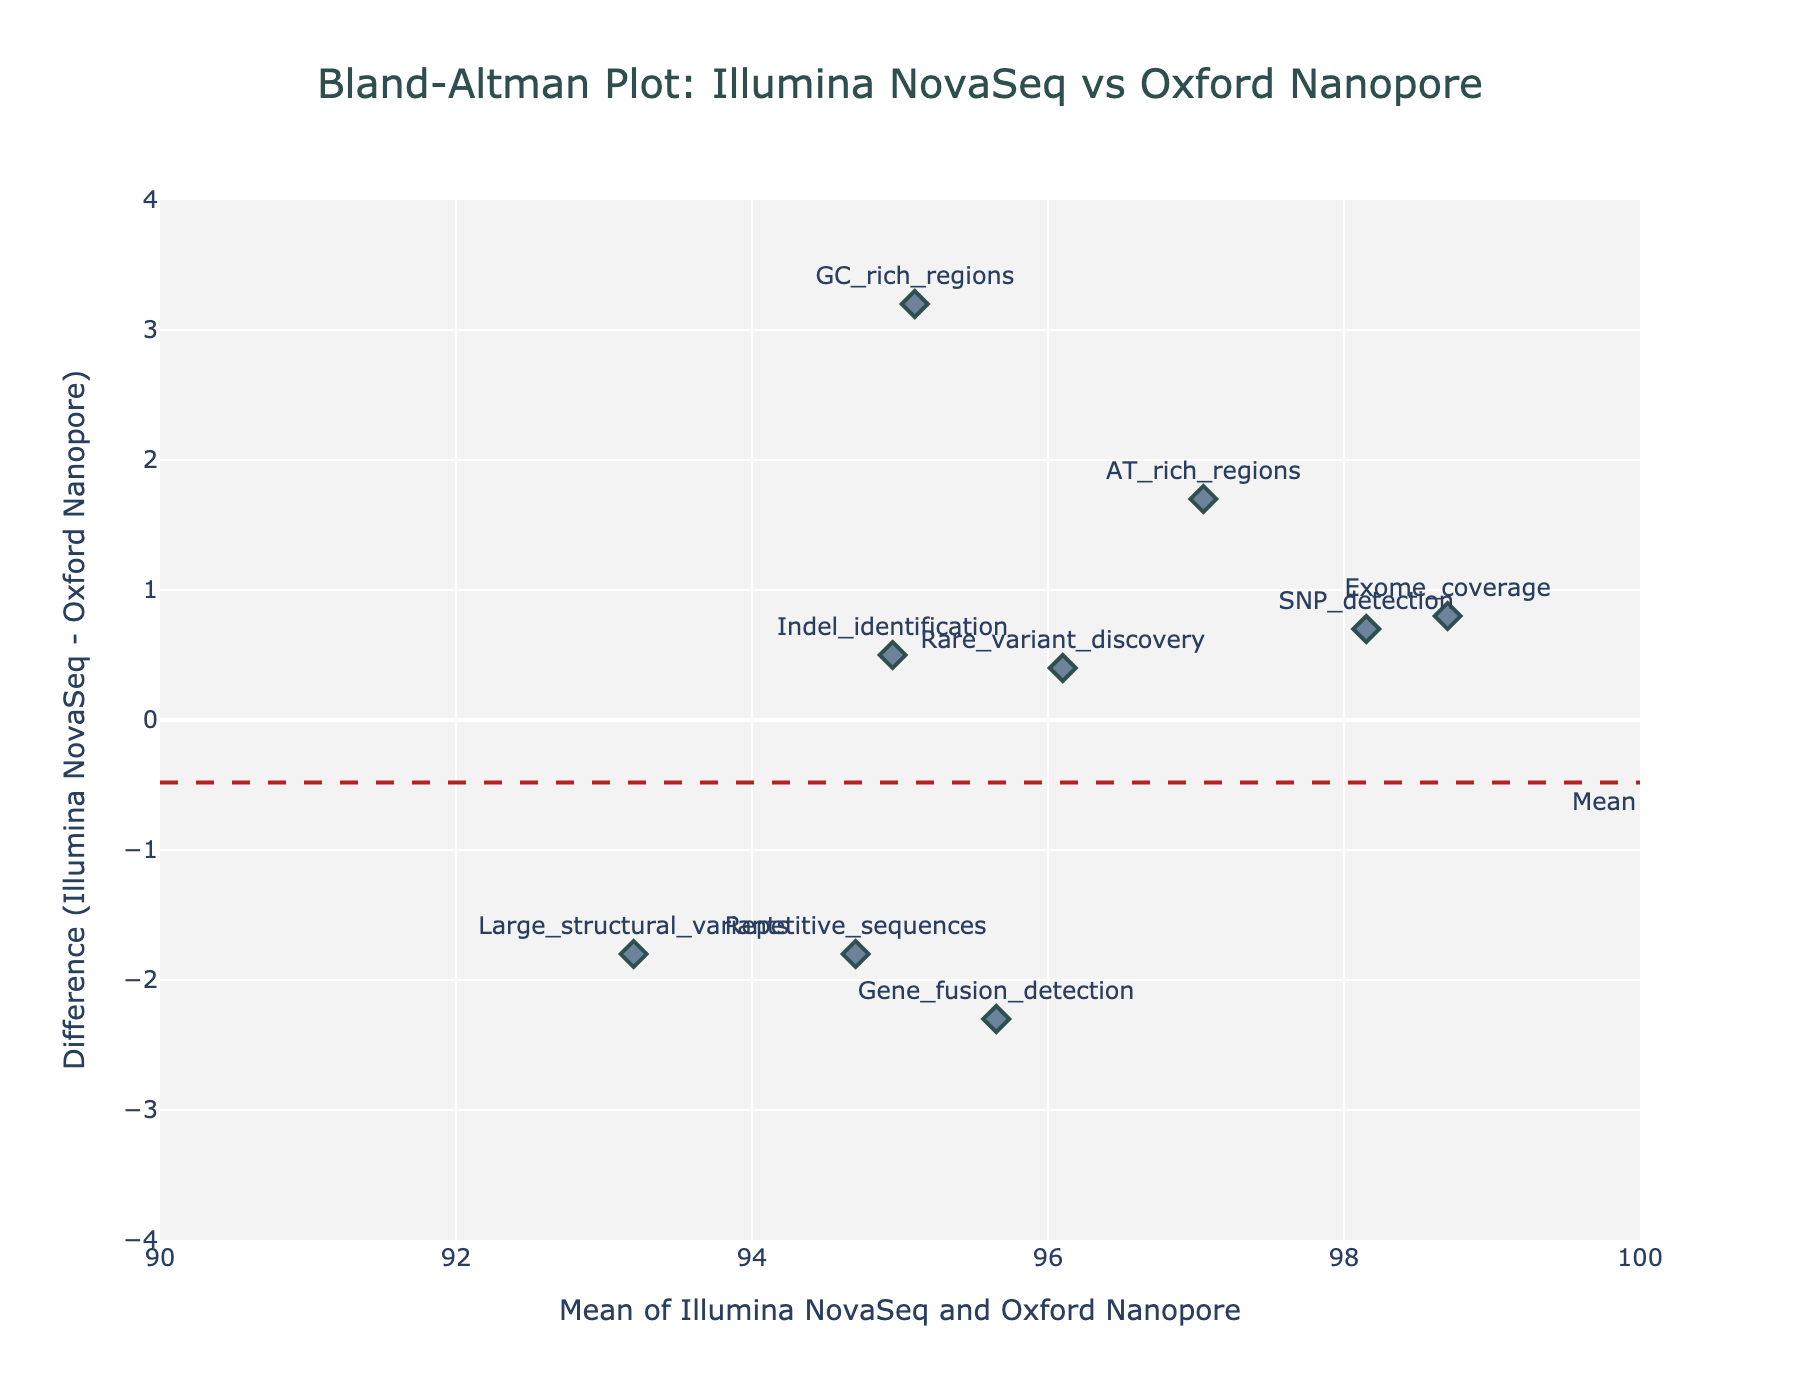How many data points are plotted in the figure? The plot displays one marker for each data point corresponding to a method on the x and y axes. By counting the markers with text labels in the plot, you get the total number of data points.
Answer: 10 What is the title of the plot? The title is located at the top of the plot, usually in a larger and bolder font. It provides an overview of the plot’s purpose.
Answer: Bland-Altman Plot: Illumina NovaSeq vs Oxford Nanopore What does the y-axis represent? The y-axis label is on the left side of the plot. It indicates what the data points' vertical positions represent.
Answer: Difference (Illumina NovaSeq - Oxford Nanopore) Which data point has the largest positive difference? The data point with the highest position on the y-axis is the one with the largest positive difference. You can identify it by looking at the topmost point and checking its label.
Answer: Methylation_analysis What are the Upper and Lower Limits of Agreement (LoA) in the plot? The Upper and Lower LoA are shown as dashed lines on the plot. The corresponding y-values can be read from the annotations next to these lines.
Answer: Approximately 2.4 (Upper LoA) and -2.4 (Lower LoA) What is the mean difference in the plot, and how is it represented? The mean difference is the central dashed line in the plot, typically annotated as "Mean." Read its y-value from the annotation.
Answer: The mean difference is 0 Between which two points is the largest visual difference in their average values? By comparing the positions on the x-axis, the two farthest data points represent the largest visual difference in their average values. Identify these points by looking at the extremities on the x-axis.
Answer: Exome_coverage and Methylation_analysis For which genetic feature is the difference closest to zero? Find the data point that is nearest the y=0 line, indicating the smallest difference.
Answer: Rare_variant_discovery Which method generally shows higher values for GC-rich regions, given the difference pattern? For GC-rich regions, observe if the difference is above or below zero. Above zero indicates Illumina NovaSeq shows higher values and below zero indicates Oxford Nanopore shows higher values.
Answer: Illumina NovaSeq How many points lie outside the Limits of Agreement? Points outside the LoA are those above the Upper LoA or below the Lower LoA. Count these points in the plot.
Answer: 0 